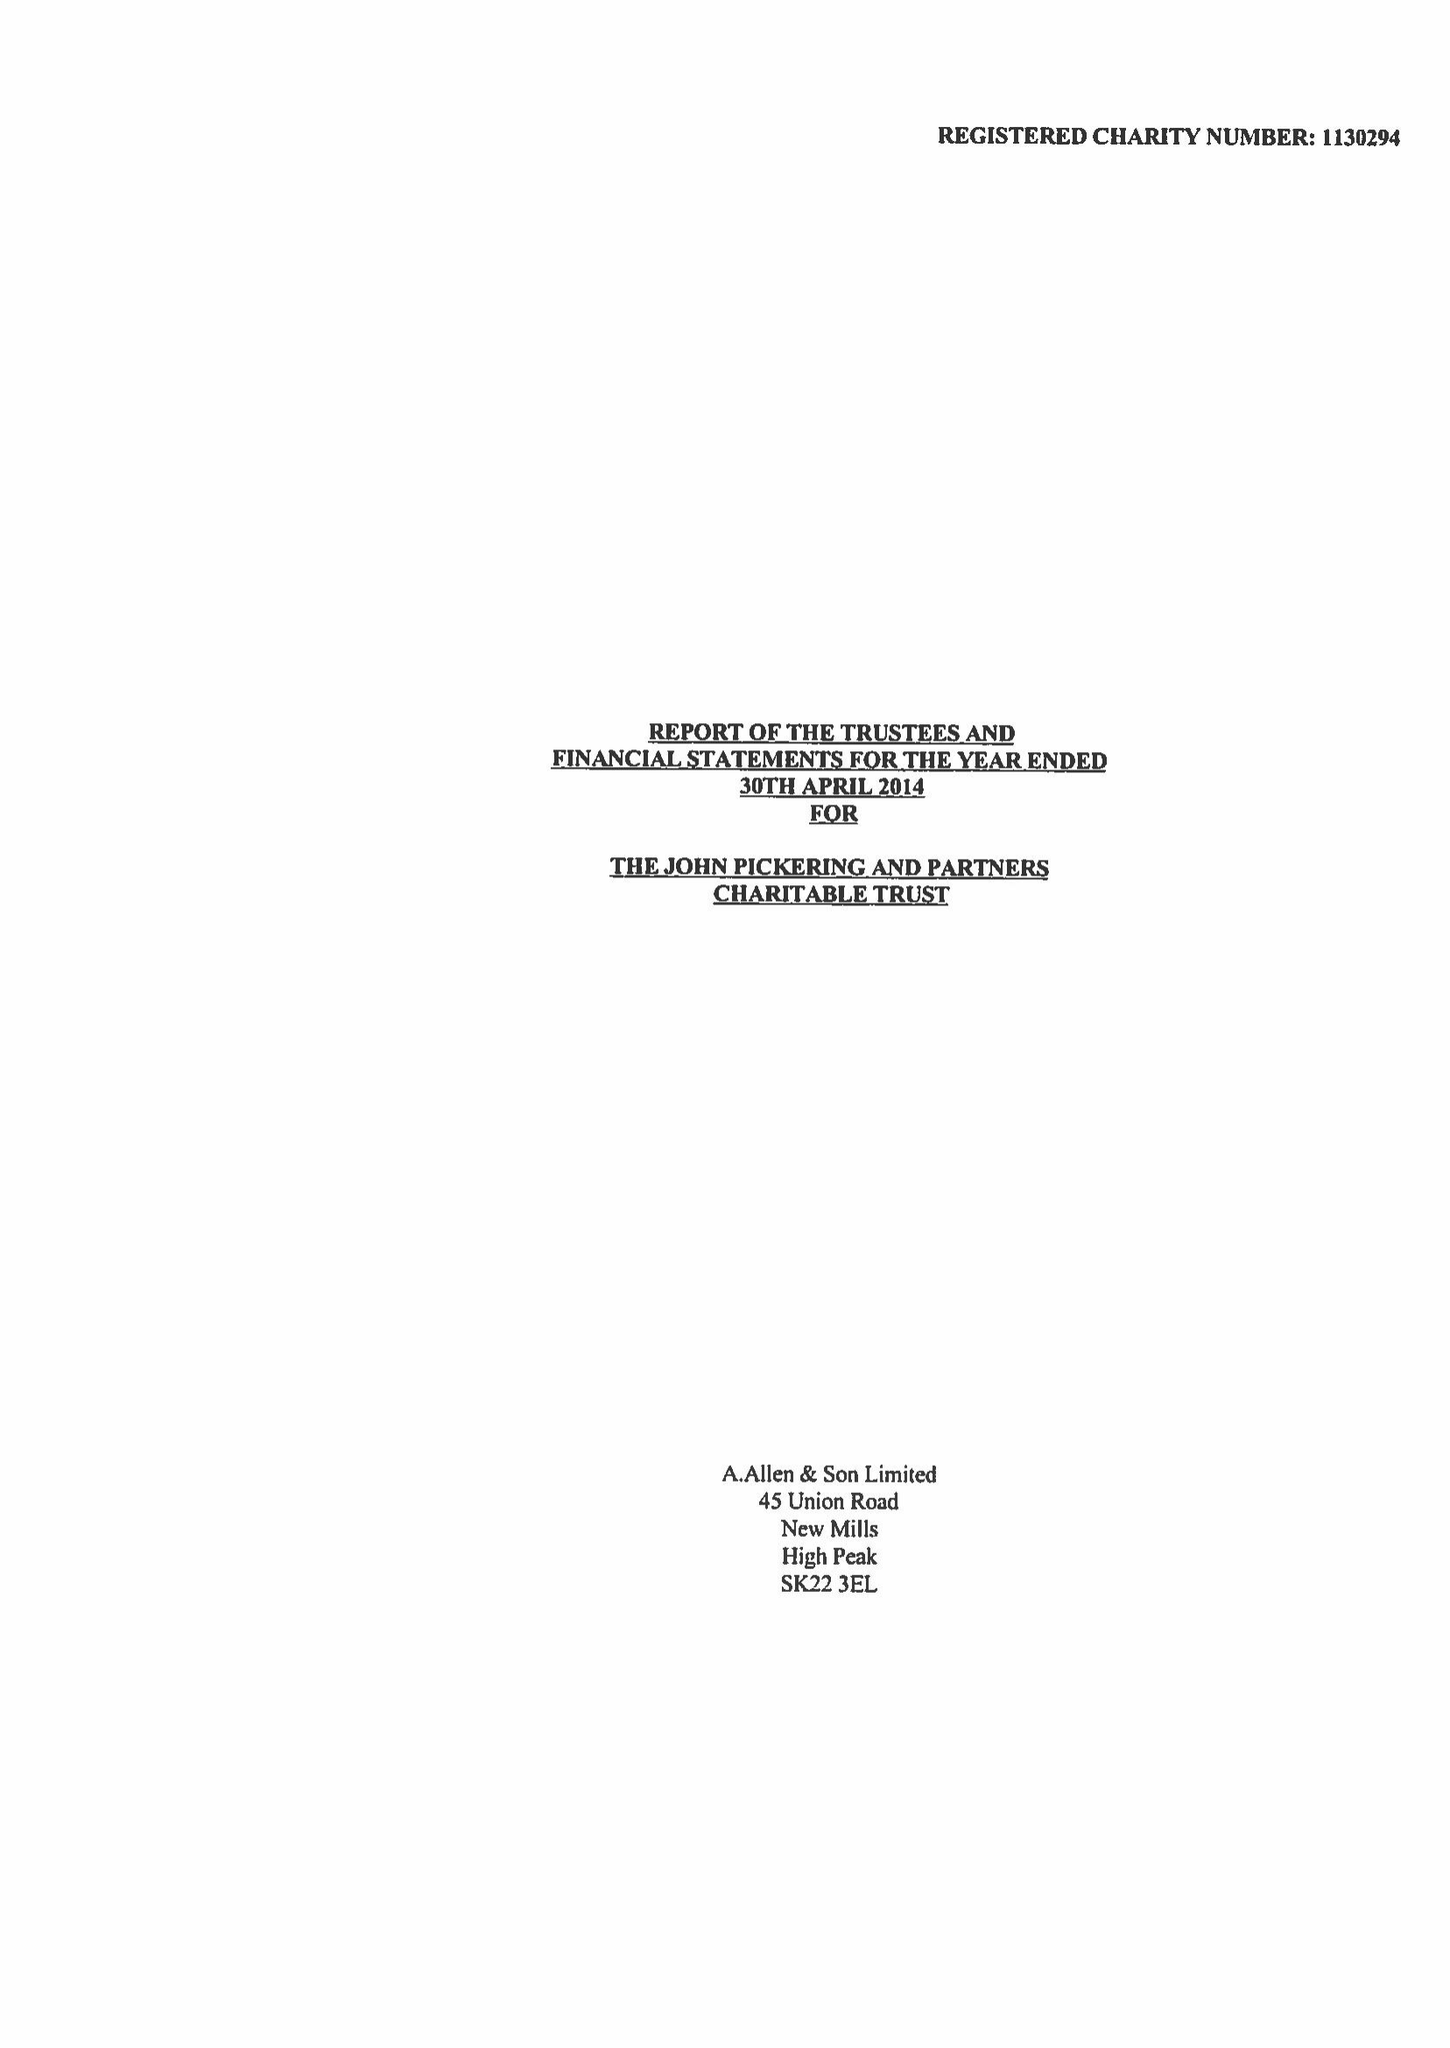What is the value for the address__street_line?
Answer the question using a single word or phrase. 45 UNION ROAD 